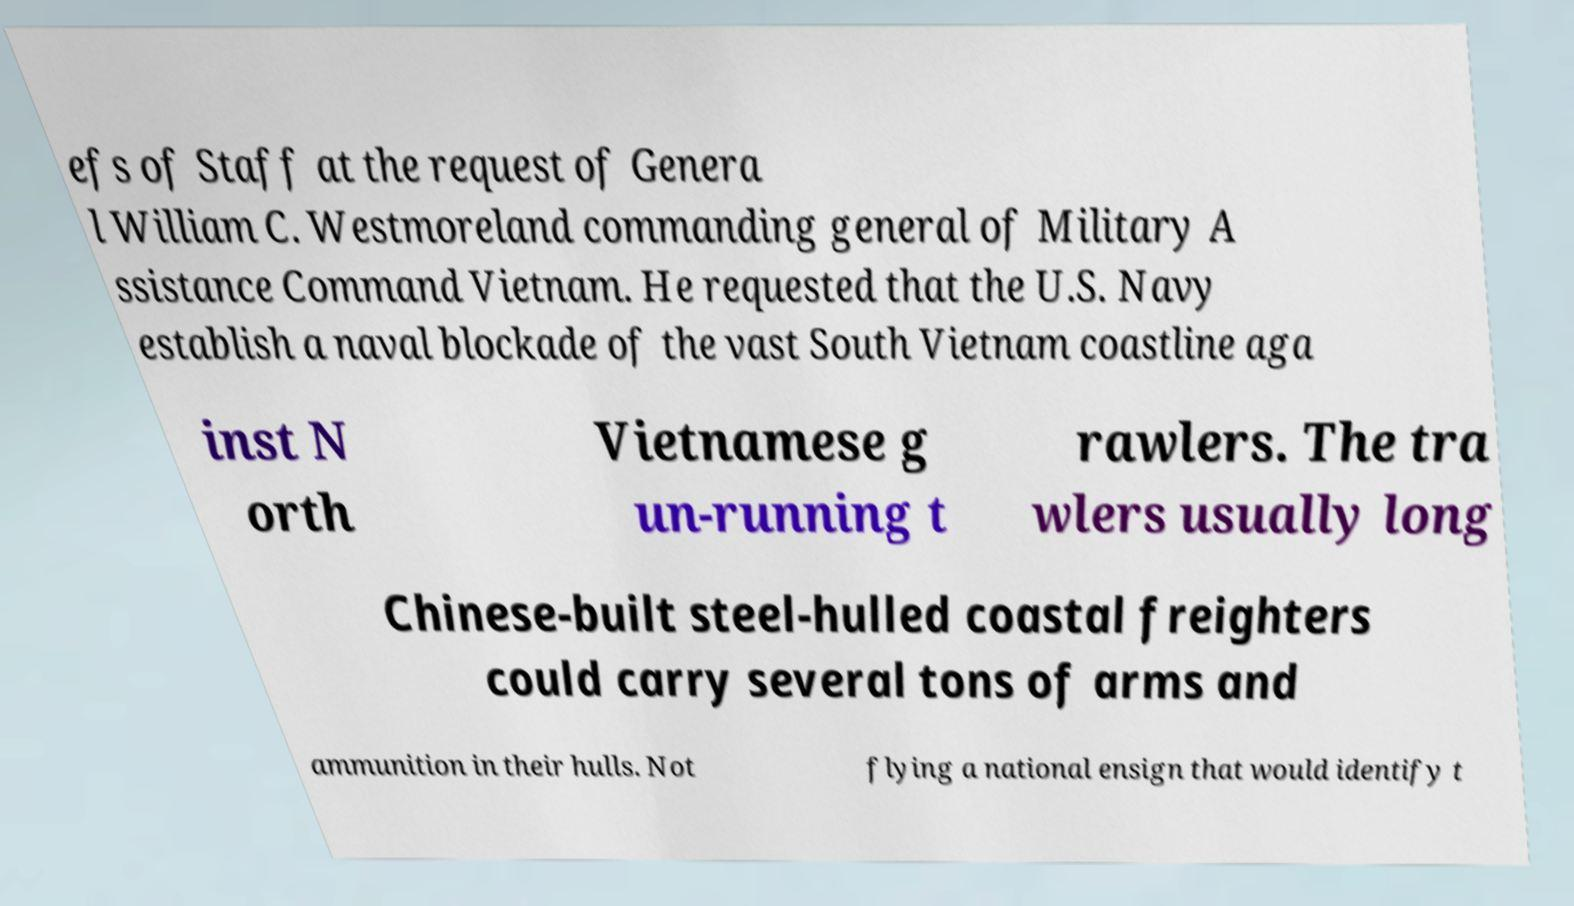Can you accurately transcribe the text from the provided image for me? efs of Staff at the request of Genera l William C. Westmoreland commanding general of Military A ssistance Command Vietnam. He requested that the U.S. Navy establish a naval blockade of the vast South Vietnam coastline aga inst N orth Vietnamese g un-running t rawlers. The tra wlers usually long Chinese-built steel-hulled coastal freighters could carry several tons of arms and ammunition in their hulls. Not flying a national ensign that would identify t 